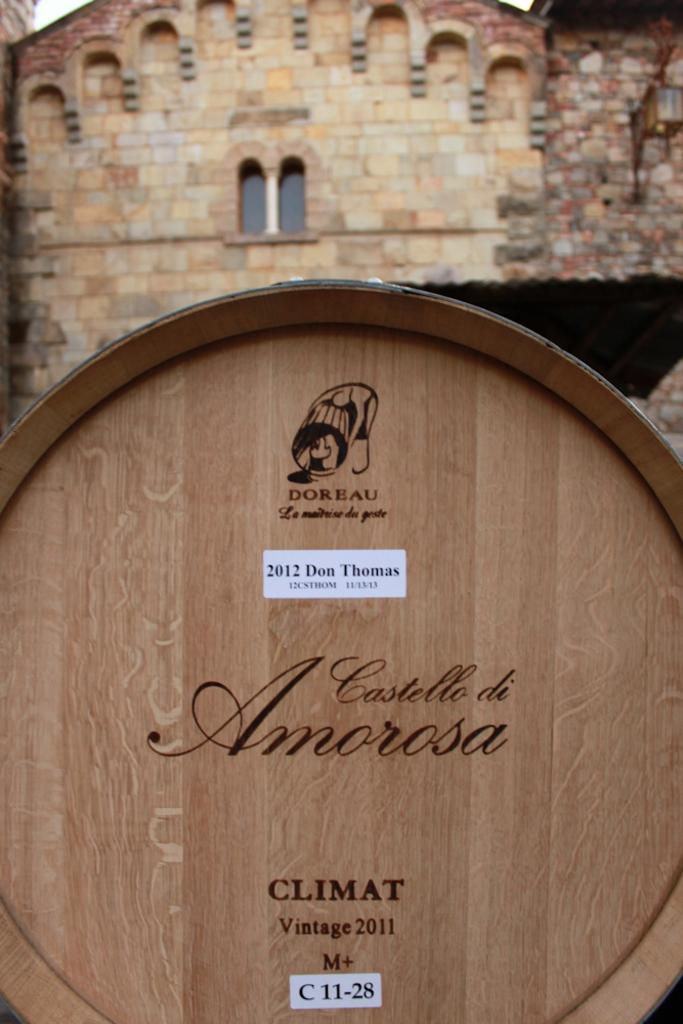What is written on the wooden board in the image? There is a wooden board with text in the image, but the specific text is not mentioned in the facts. What type of structure is visible in the image? There is a house in the image. What architectural feature can be seen in the house? There is a window in the image. What color is the blood on the rail in the image? There is no rail or blood present in the image. How many people are resting in the house in the image? The number of people and their activities are not mentioned in the facts, so we cannot determine if anyone is resting in the house. 